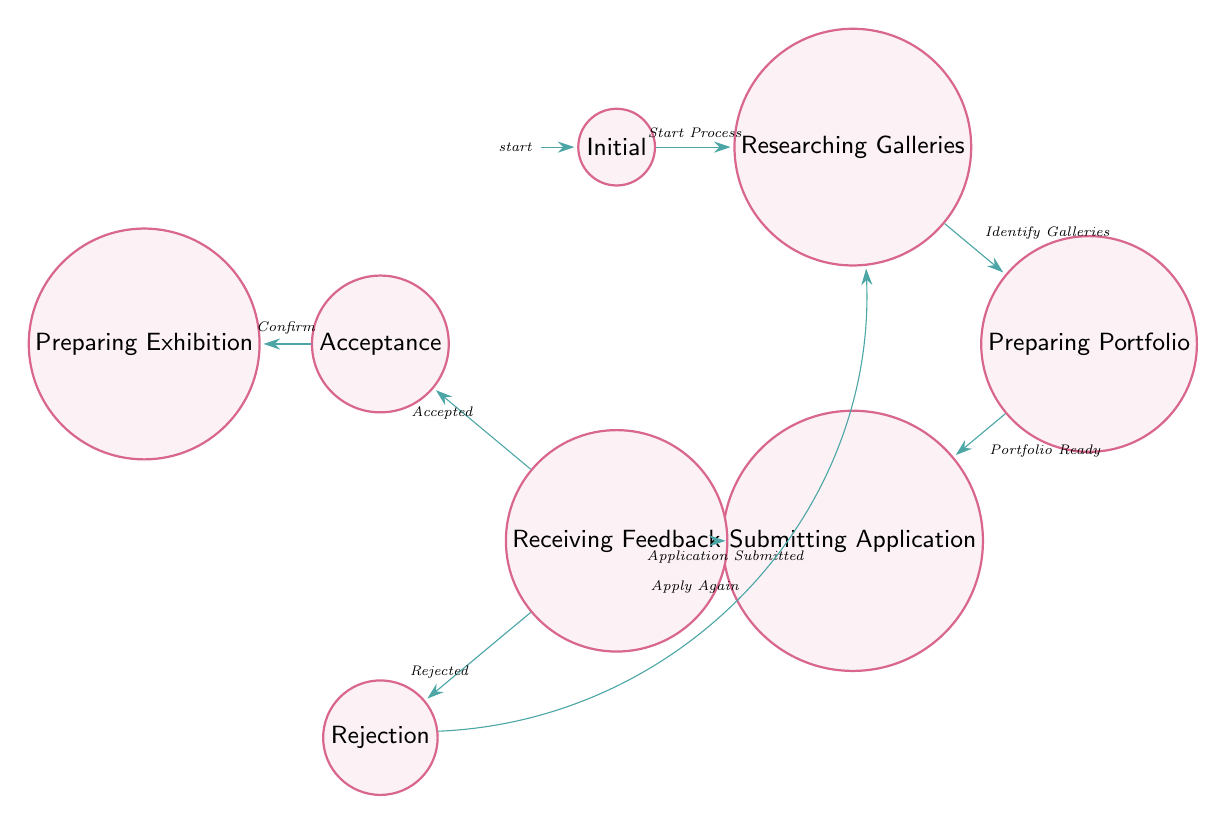What is the starting state of the diagram? The initial state from which the journey begins is labeled "Initial" on the diagram.
Answer: Initial How many total states are present in the diagram? By counting the distinct states represented in the diagram, there are eight: Initial, Researching Galleries, Preparing Portfolio, Submitting Application, Receiving Feedback, Acceptance, Rejection, and Preparing Exhibition.
Answer: Eight What action leads to the "Preparing Portfolio" state? The transition leading to the "Preparing Portfolio" state is triggered by identifying potential galleries, indicated in the diagram by the edge labeled "Identify Galleries."
Answer: Identify Galleries What happens after receiving feedback if the application is rejected? If the application is rejected, the process returns to the "Researching Galleries" state, as shown by the transition labeled "Apply Again" which loops back to that state.
Answer: Researching Galleries What is the final state if the application is accepted? Upon acceptance of the application, the next state is "Preparing Exhibition," which follows the edge labeled "Confirm" from "Acceptance."
Answer: Preparing Exhibition How many edges connect the "Receiving Feedback" state to other states? The "Receiving Feedback" state connects to two other states: "Acceptance" and "Rejection," represented by two edges stemming from this state.
Answer: Two What is the action required before submitting an application? Prior to submitting the application, the action required is to ensure the portfolio is ready, denoted in the diagram by the transition "Portfolio Ready."
Answer: Portfolio Ready Which state follows the "Submitting Application" state? After the "Submitting Application" state, the next state is "Receiving Feedback," as indicated by the transition marked "Application Submitted."
Answer: Receiving Feedback What is the primary purpose of the "Preparing Portfolio" state? The primary purpose of this state is to curate and refine the artist's portfolio to showcase the best work, as described in the state’s description within the diagram.
Answer: Curate and refine portfolio 